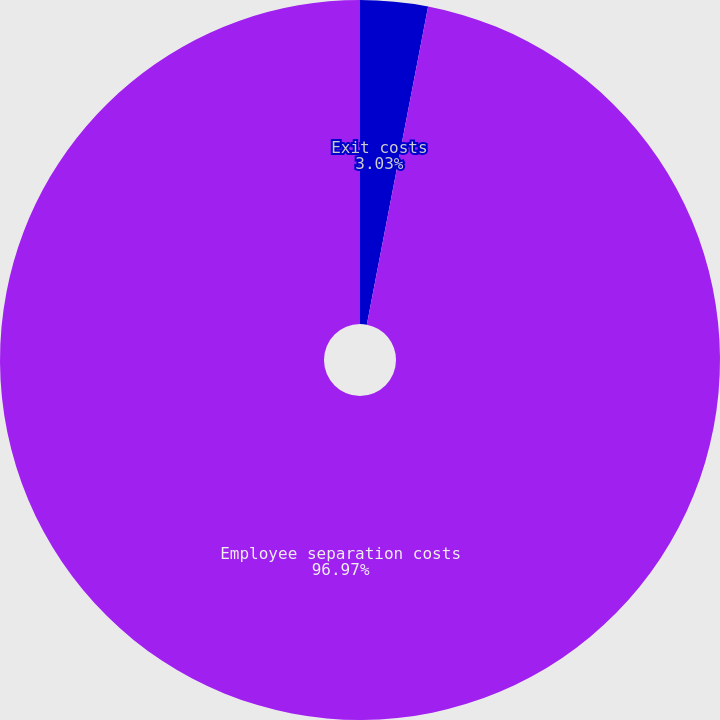Convert chart. <chart><loc_0><loc_0><loc_500><loc_500><pie_chart><fcel>Exit costs<fcel>Employee separation costs<nl><fcel>3.03%<fcel>96.97%<nl></chart> 